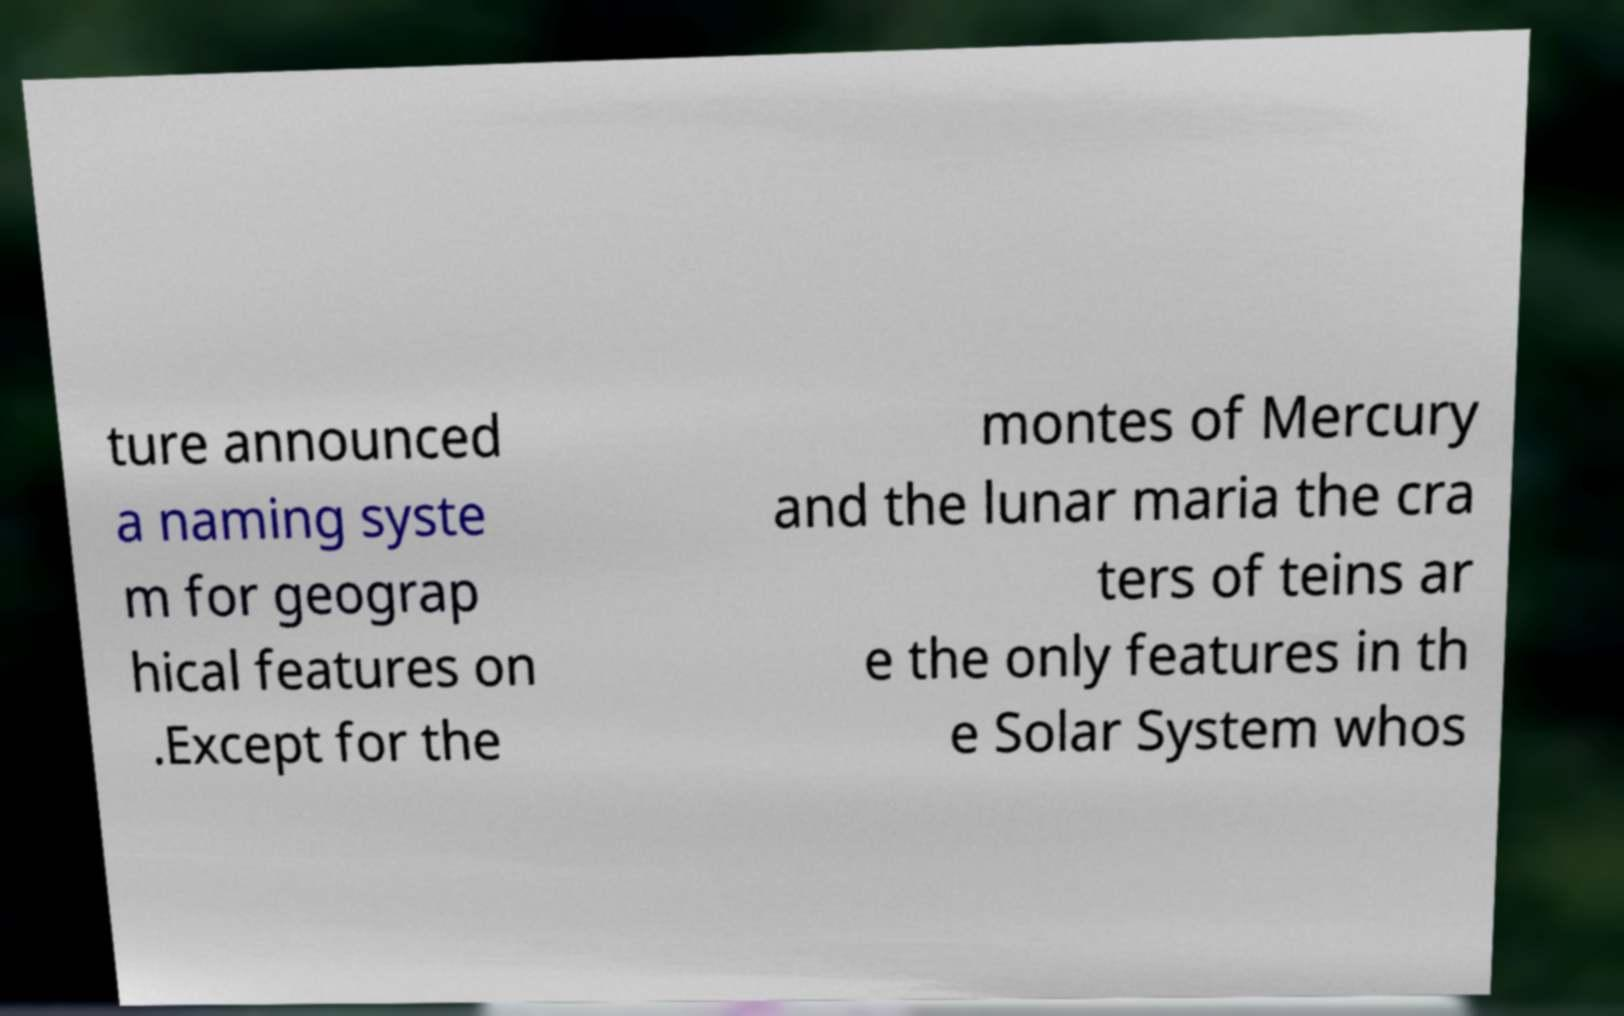Could you extract and type out the text from this image? ture announced a naming syste m for geograp hical features on .Except for the montes of Mercury and the lunar maria the cra ters of teins ar e the only features in th e Solar System whos 